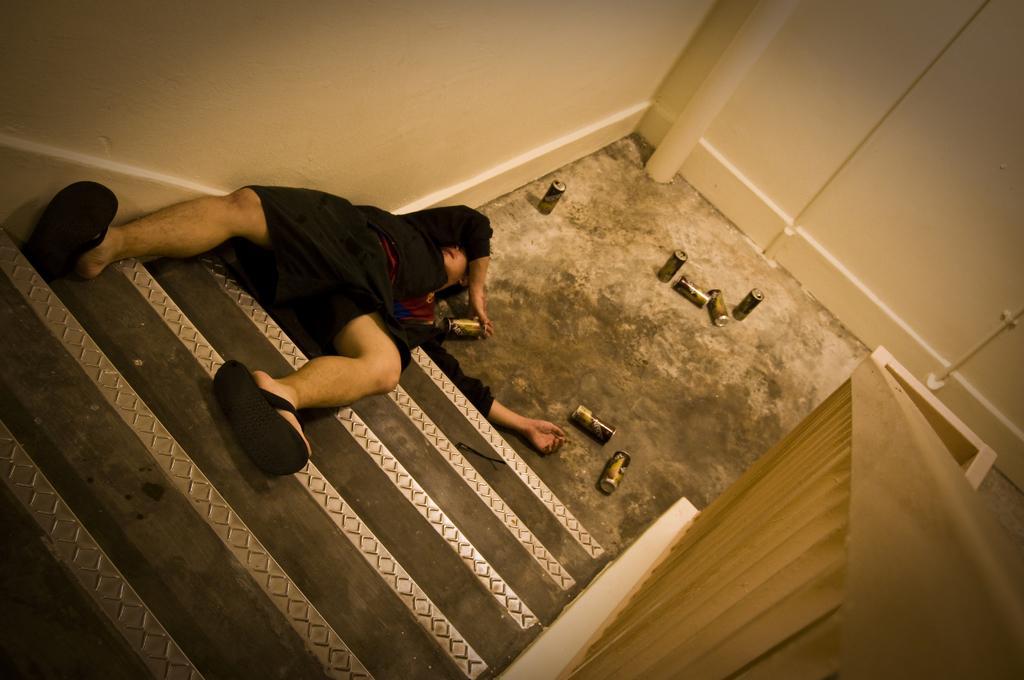In one or two sentences, can you explain what this image depicts? In this image we can see a man is lying on the staircase, there are the twins on the ground, there is the wall, there is the steel railing. 